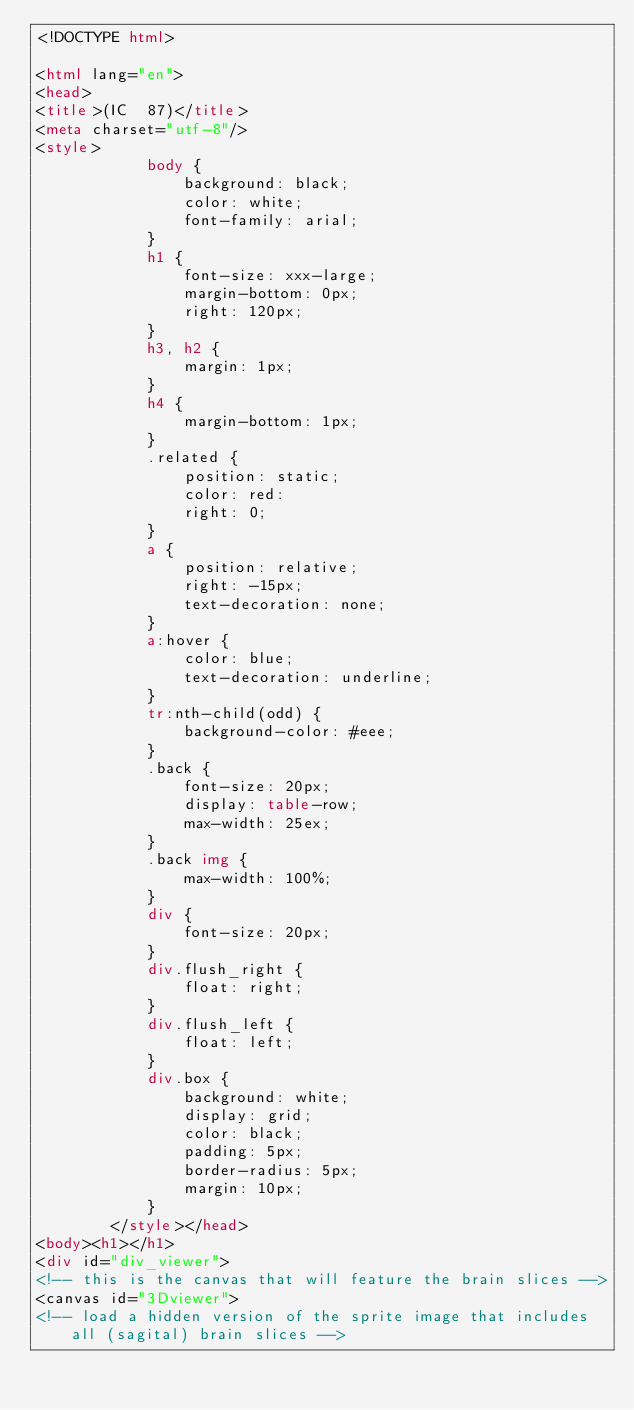Convert code to text. <code><loc_0><loc_0><loc_500><loc_500><_HTML_><!DOCTYPE html>

<html lang="en">
<head>
<title>(IC  87)</title>
<meta charset="utf-8"/>
<style>
            body {
                background: black;
                color: white;
                font-family: arial;
            }
            h1 {
                font-size: xxx-large;
                margin-bottom: 0px;
                right: 120px;
            }
            h3, h2 {
                margin: 1px;
            }
            h4 {
                margin-bottom: 1px;
            }
            .related {
                position: static;
                color: red:
                right: 0;
            }
            a {
                position: relative;
                right: -15px;
                text-decoration: none;
            }
            a:hover {
                color: blue;
                text-decoration: underline;
            }
            tr:nth-child(odd) {
                background-color: #eee;
            }
            .back {
                font-size: 20px;
                display: table-row;
                max-width: 25ex;
            }
            .back img {
                max-width: 100%;
            }
            div {
                font-size: 20px;
            }
            div.flush_right {
                float: right;
            }
            div.flush_left {
                float: left;
            }
            div.box {
                background: white;
                display: grid;
                color: black;
                padding: 5px;
                border-radius: 5px;
                margin: 10px;
            }
        </style></head>
<body><h1></h1>
<div id="div_viewer">
<!-- this is the canvas that will feature the brain slices -->
<canvas id="3Dviewer">
<!-- load a hidden version of the sprite image that includes all (sagital) brain slices --></code> 